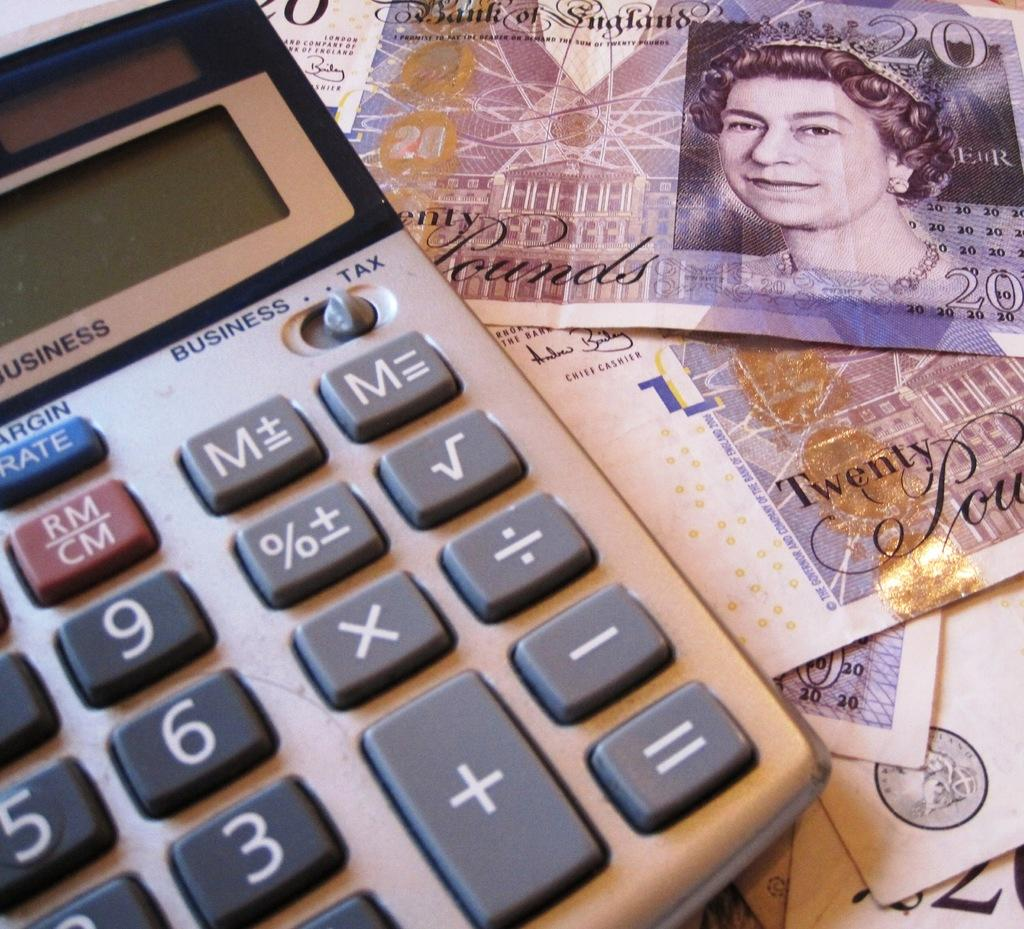What type of financial items can be seen in the image? There is money in the image. What else can be seen in the image besides money? There are cards and a calculator visible in the image. What type of dinosaurs can be seen walking on the sidewalk in the image? There are no dinosaurs or sidewalks present in the image. 